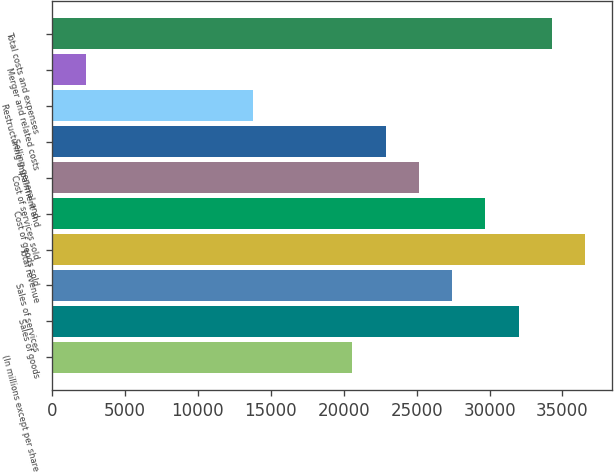Convert chart. <chart><loc_0><loc_0><loc_500><loc_500><bar_chart><fcel>(In millions except per share<fcel>Sales of goods<fcel>Sales of services<fcel>Total revenue<fcel>Cost of goods sold<fcel>Cost of services sold<fcel>Selling general and<fcel>Restructuring impairment and<fcel>Merger and related costs<fcel>Total costs and expenses<nl><fcel>20598.1<fcel>31992.6<fcel>27434.8<fcel>36550.4<fcel>29713.7<fcel>25155.9<fcel>22877<fcel>13761.4<fcel>2366.9<fcel>34271.5<nl></chart> 